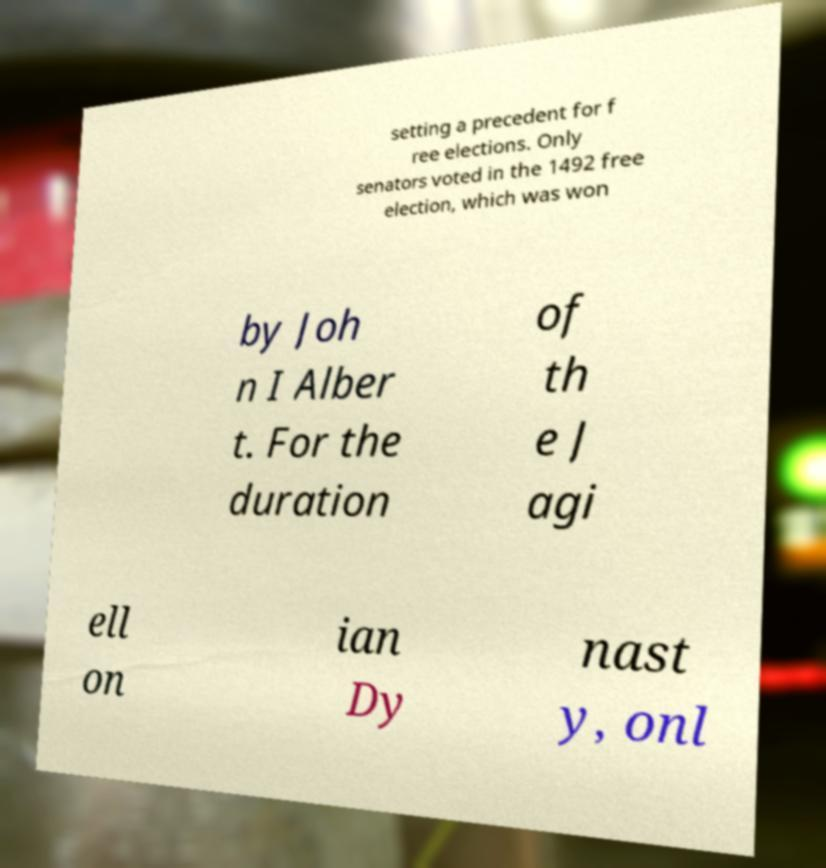Can you accurately transcribe the text from the provided image for me? setting a precedent for f ree elections. Only senators voted in the 1492 free election, which was won by Joh n I Alber t. For the duration of th e J agi ell on ian Dy nast y, onl 